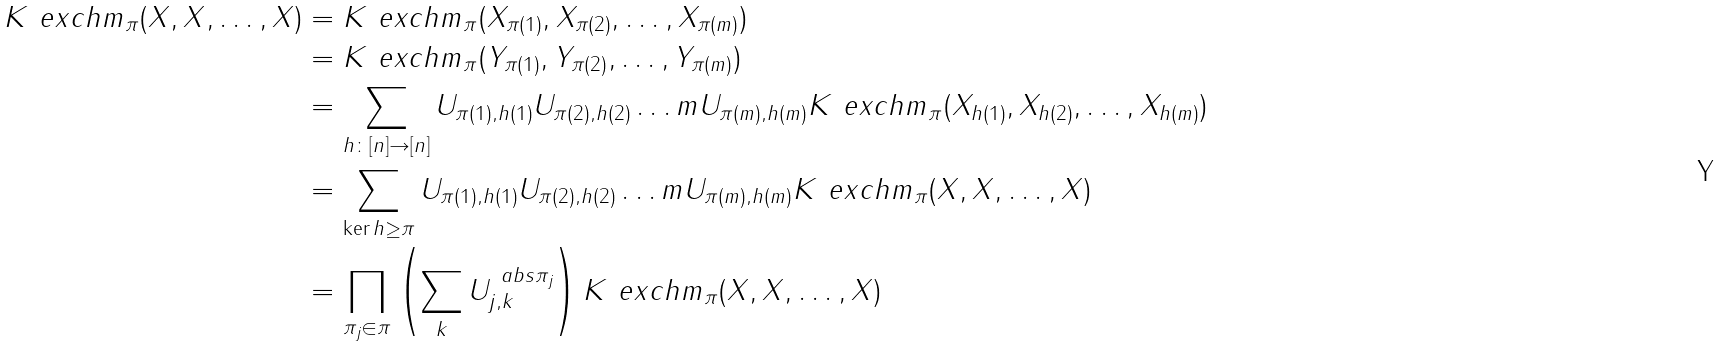Convert formula to latex. <formula><loc_0><loc_0><loc_500><loc_500>K ^ { \ } e x c h m _ { \pi } ( X , X , \dots , X ) & = K ^ { \ } e x c h m _ { \pi } ( X _ { \pi ( 1 ) } , X _ { \pi ( 2 ) } , \dots , X _ { \pi ( m ) } ) \\ & = K ^ { \ } e x c h m _ { \pi } ( Y _ { \pi ( 1 ) } , Y _ { \pi ( 2 ) } , \dots , Y _ { \pi ( m ) } ) \\ & = \sum _ { h \colon [ n ] \to [ n ] } U _ { \pi ( 1 ) , h ( 1 ) } U _ { \pi ( 2 ) , h ( 2 ) } \dots m U _ { \pi ( m ) , h ( m ) } K ^ { \ } e x c h m _ { \pi } ( X _ { h ( 1 ) } , X _ { h ( 2 ) } , \dots , X _ { h ( m ) } ) \\ & = \sum _ { \ker h \geq \pi } U _ { \pi ( 1 ) , h ( 1 ) } U _ { \pi ( 2 ) , h ( 2 ) } \dots m U _ { \pi ( m ) , h ( m ) } K ^ { \ } e x c h m _ { \pi } ( X , X , \dots , X ) \\ & = \prod _ { \pi _ { j } \in \pi } \left ( \sum _ { k } U _ { j , k } ^ { \ a b s { \pi _ { j } } } \right ) K ^ { \ } e x c h m _ { \pi } ( X , X , \dots , X ) \\</formula> 